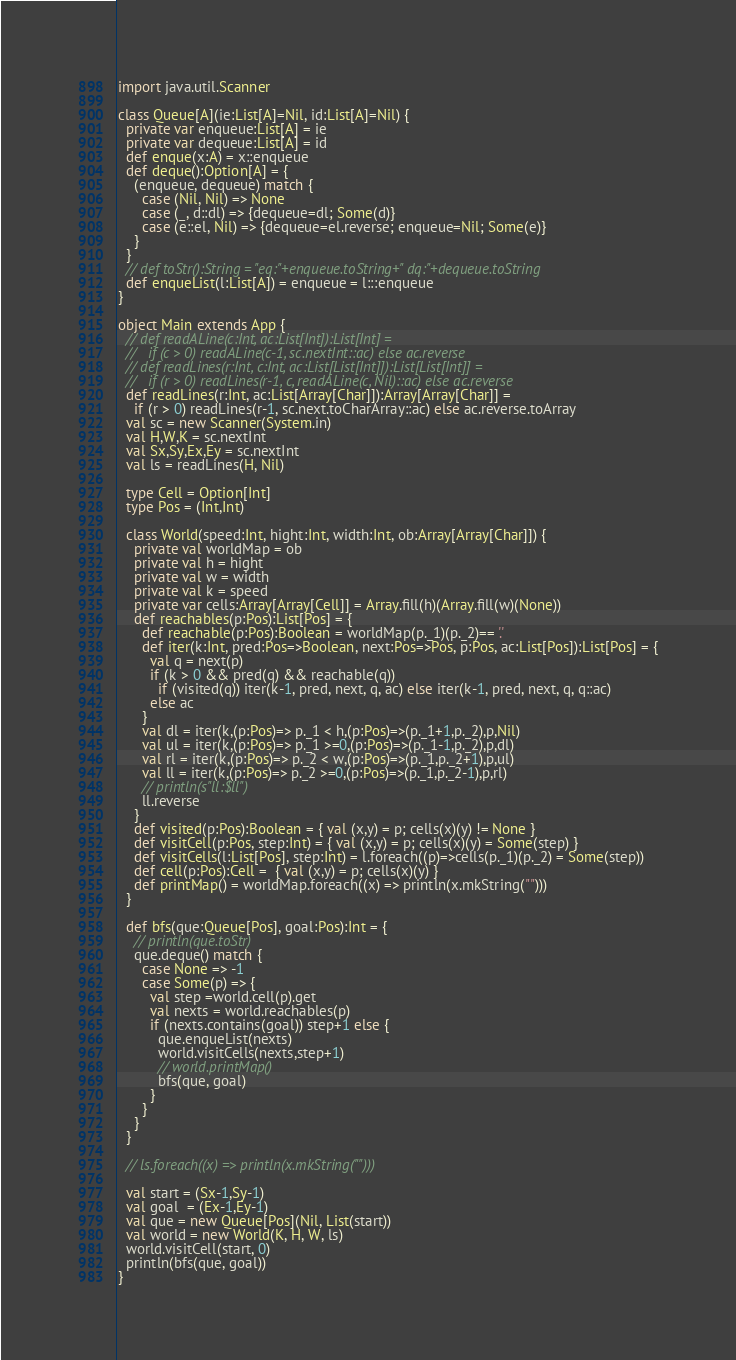<code> <loc_0><loc_0><loc_500><loc_500><_Scala_>import java.util.Scanner

class Queue[A](ie:List[A]=Nil, id:List[A]=Nil) {
  private var enqueue:List[A] = ie
  private var dequeue:List[A] = id
  def enque(x:A) = x::enqueue
  def deque():Option[A] = {
    (enqueue, dequeue) match {
      case (Nil, Nil) => None
      case (_, d::dl) => {dequeue=dl; Some(d)}
      case (e::el, Nil) => {dequeue=el.reverse; enqueue=Nil; Some(e)}
    }
  }
  // def toStr():String = "eq:"+enqueue.toString+" dq:"+dequeue.toString
  def enqueList(l:List[A]) = enqueue = l:::enqueue
}

object Main extends App {
  // def readALine(c:Int, ac:List[Int]):List[Int] =
  //   if (c > 0) readALine(c-1, sc.nextInt::ac) else ac.reverse
  // def readLines(r:Int, c:Int, ac:List[List[Int]]):List[List[Int]] =
  //   if (r > 0) readLines(r-1, c, readALine(c, Nil)::ac) else ac.reverse
  def readLines(r:Int, ac:List[Array[Char]]):Array[Array[Char]] =
    if (r > 0) readLines(r-1, sc.next.toCharArray::ac) else ac.reverse.toArray
  val sc = new Scanner(System.in)
  val H,W,K = sc.nextInt
  val Sx,Sy,Ex,Ey = sc.nextInt
  val ls = readLines(H, Nil)

  type Cell = Option[Int]
  type Pos = (Int,Int)

  class World(speed:Int, hight:Int, width:Int, ob:Array[Array[Char]]) {
    private val worldMap = ob
    private val h = hight
    private val w = width
    private val k = speed
    private var cells:Array[Array[Cell]] = Array.fill(h)(Array.fill(w)(None))
    def reachables(p:Pos):List[Pos] = {
      def reachable(p:Pos):Boolean = worldMap(p._1)(p._2)== '.'
      def iter(k:Int, pred:Pos=>Boolean, next:Pos=>Pos, p:Pos, ac:List[Pos]):List[Pos] = {
        val q = next(p)
        if (k > 0 && pred(q) && reachable(q))
          if (visited(q)) iter(k-1, pred, next, q, ac) else iter(k-1, pred, next, q, q::ac)
        else ac
      }
      val dl = iter(k,(p:Pos)=> p._1 < h,(p:Pos)=>(p._1+1,p._2),p,Nil)
      val ul = iter(k,(p:Pos)=> p._1 >=0,(p:Pos)=>(p._1-1,p._2),p,dl)
      val rl = iter(k,(p:Pos)=> p._2 < w,(p:Pos)=>(p._1,p._2+1),p,ul)
      val ll = iter(k,(p:Pos)=> p._2 >=0,(p:Pos)=>(p._1,p._2-1),p,rl)
      // println(s"ll:$ll")
      ll.reverse
    }
    def visited(p:Pos):Boolean = { val (x,y) = p; cells(x)(y) != None }
    def visitCell(p:Pos, step:Int) = { val (x,y) = p; cells(x)(y) = Some(step) }
    def visitCells(l:List[Pos], step:Int) = l.foreach((p)=>cells(p._1)(p._2) = Some(step))
    def cell(p:Pos):Cell =  { val (x,y) = p; cells(x)(y) }
    def printMap() = worldMap.foreach((x) => println(x.mkString("")))
  }

  def bfs(que:Queue[Pos], goal:Pos):Int = {
    // println(que.toStr)
    que.deque() match {
      case None => -1
      case Some(p) => {
        val step =world.cell(p).get
        val nexts = world.reachables(p)
        if (nexts.contains(goal)) step+1 else {
          que.enqueList(nexts)
          world.visitCells(nexts,step+1)
          // world.printMap()
          bfs(que, goal)
        }
      }
    }
  }

  // ls.foreach((x) => println(x.mkString("")))

  val start = (Sx-1,Sy-1)
  val goal  = (Ex-1,Ey-1)
  val que = new Queue[Pos](Nil, List(start))
  val world = new World(K, H, W, ls)
  world.visitCell(start, 0)
  println(bfs(que, goal))
}</code> 